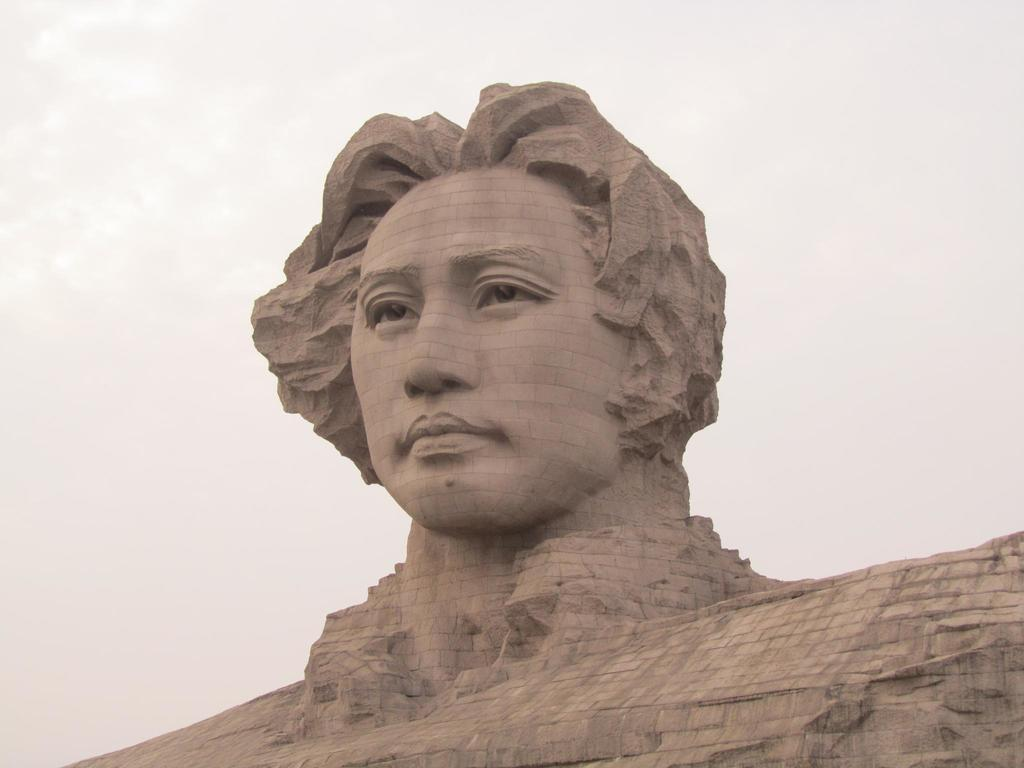What is the main subject of the image? There is a statue of a person in the image. What can be seen in the background of the image? The sky is visible in the background of the image. What type of amusement can be seen in the image? There is no amusement present in the image; it features a statue of a person and the sky. What kind of produce is being harvested in the image? There is no produce or harvesting activity depicted in the image. 